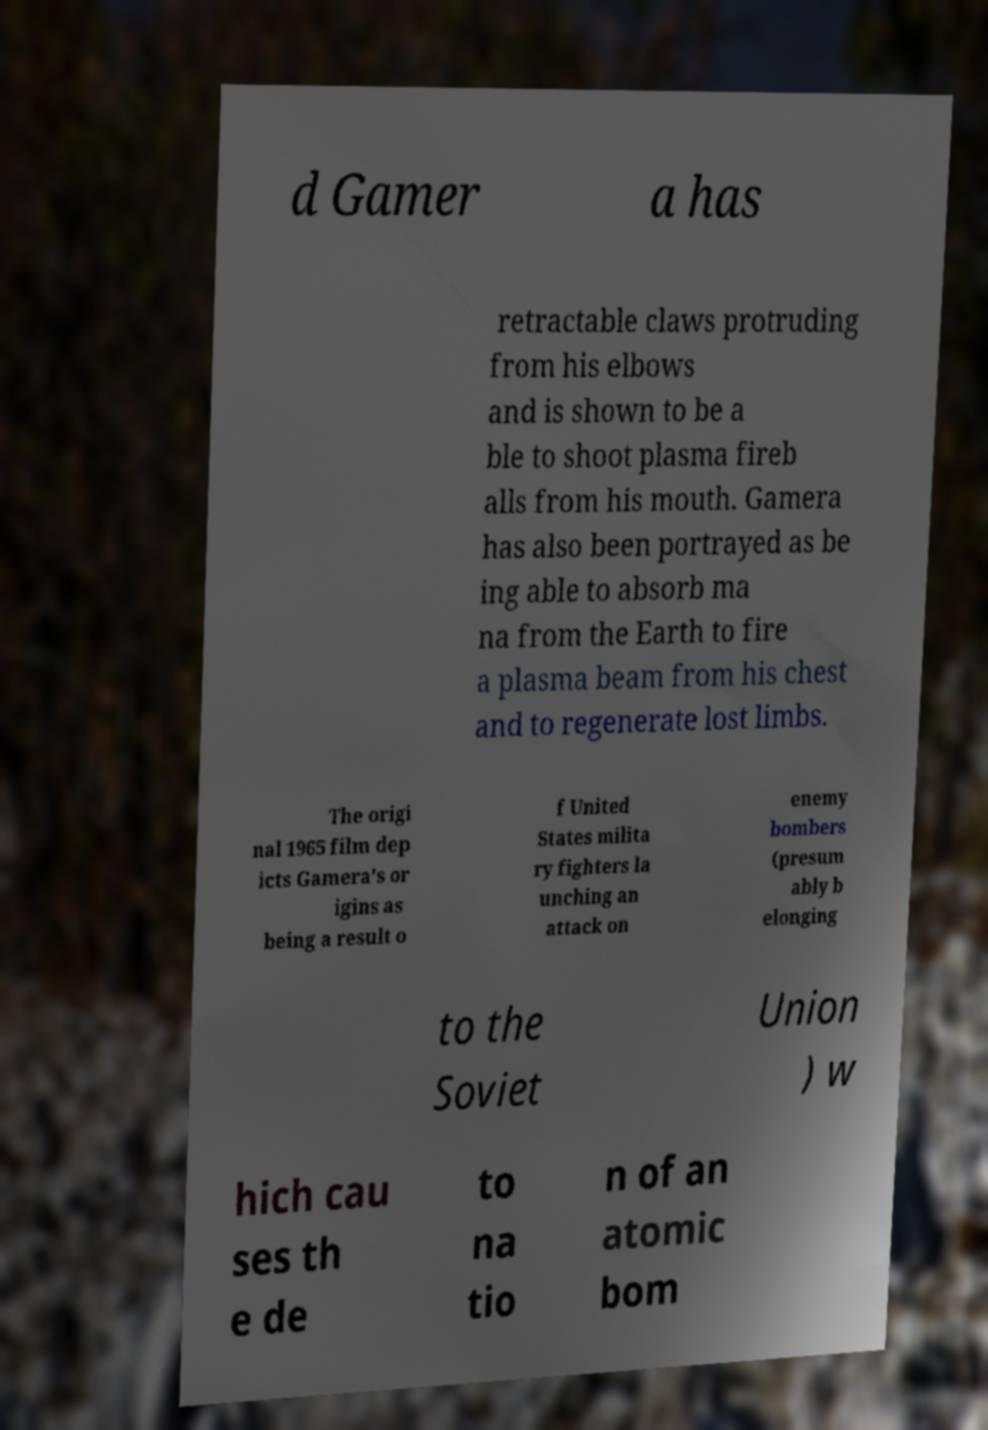Could you extract and type out the text from this image? d Gamer a has retractable claws protruding from his elbows and is shown to be a ble to shoot plasma fireb alls from his mouth. Gamera has also been portrayed as be ing able to absorb ma na from the Earth to fire a plasma beam from his chest and to regenerate lost limbs. The origi nal 1965 film dep icts Gamera's or igins as being a result o f United States milita ry fighters la unching an attack on enemy bombers (presum ably b elonging to the Soviet Union ) w hich cau ses th e de to na tio n of an atomic bom 